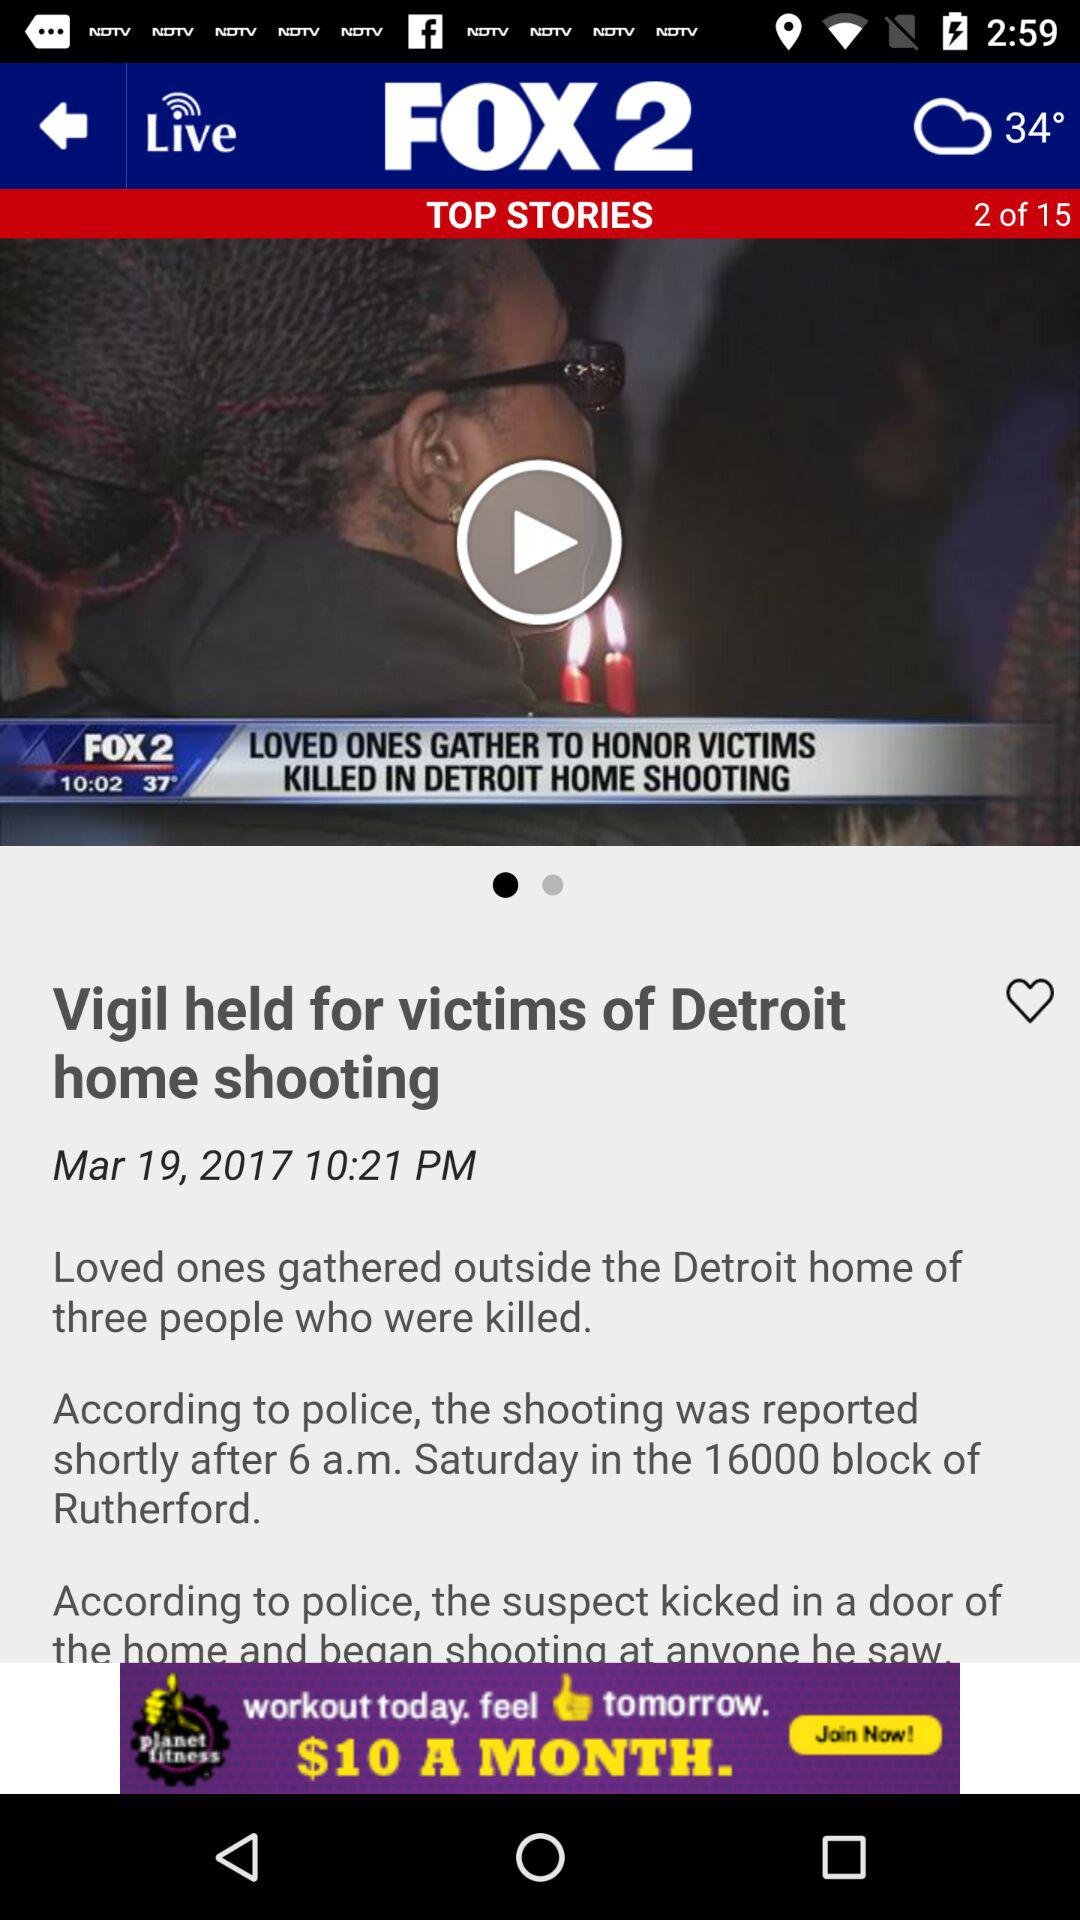When was the news published? The news was published on March 19, 2017 at 10:21 PM. 